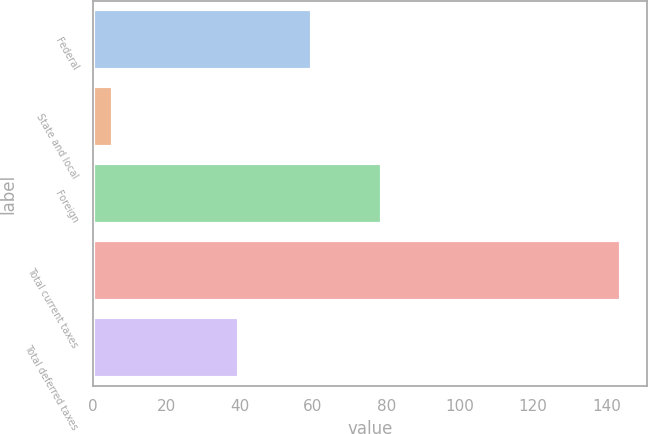Convert chart to OTSL. <chart><loc_0><loc_0><loc_500><loc_500><bar_chart><fcel>Federal<fcel>State and local<fcel>Foreign<fcel>Total current taxes<fcel>Total deferred taxes<nl><fcel>59.6<fcel>5.4<fcel>78.9<fcel>143.9<fcel>39.9<nl></chart> 